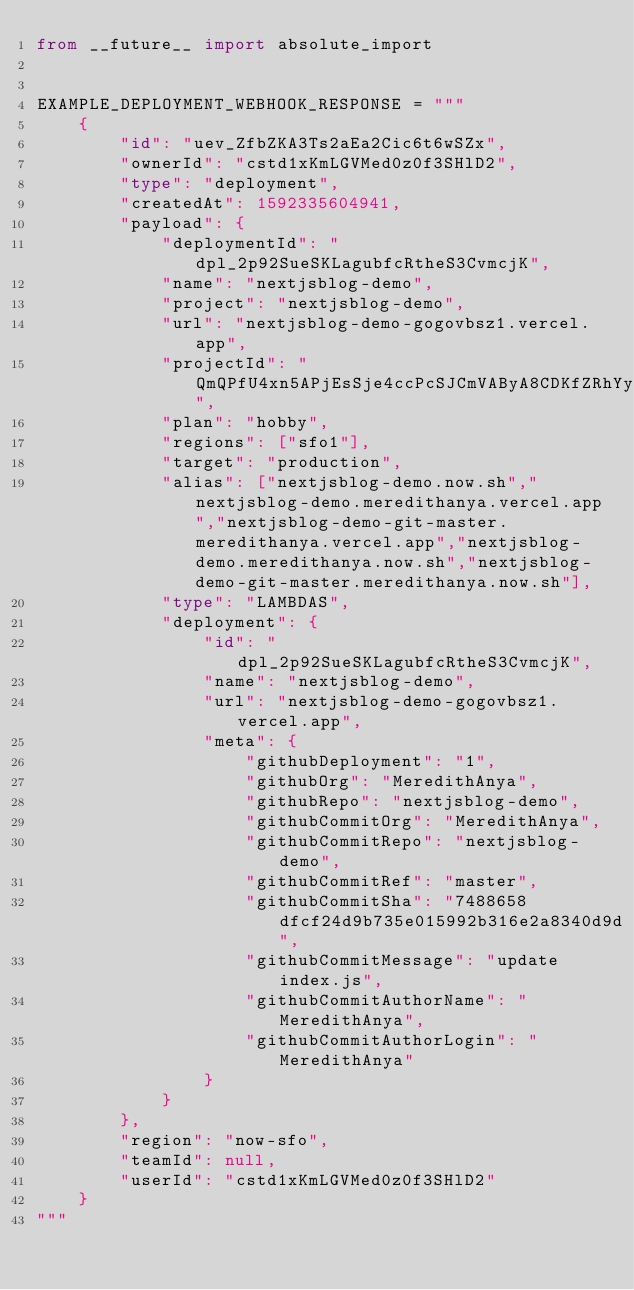<code> <loc_0><loc_0><loc_500><loc_500><_Python_>from __future__ import absolute_import


EXAMPLE_DEPLOYMENT_WEBHOOK_RESPONSE = """
    {
        "id": "uev_ZfbZKA3Ts2aEa2Cic6t6wSZx",
        "ownerId": "cstd1xKmLGVMed0z0f3SHlD2",
        "type": "deployment",
        "createdAt": 1592335604941,
        "payload": {
            "deploymentId": "dpl_2p92SueSKLagubfcRtheS3CvmcjK",
            "name": "nextjsblog-demo",
            "project": "nextjsblog-demo",
            "url": "nextjsblog-demo-gogovbsz1.vercel.app",
            "projectId": "QmQPfU4xn5APjEsSje4ccPcSJCmVAByA8CDKfZRhYyVPAg",
            "plan": "hobby",
            "regions": ["sfo1"],
            "target": "production",
            "alias": ["nextjsblog-demo.now.sh","nextjsblog-demo.meredithanya.vercel.app","nextjsblog-demo-git-master.meredithanya.vercel.app","nextjsblog-demo.meredithanya.now.sh","nextjsblog-demo-git-master.meredithanya.now.sh"],
            "type": "LAMBDAS",
            "deployment": {
                "id": "dpl_2p92SueSKLagubfcRtheS3CvmcjK",
                "name": "nextjsblog-demo",
                "url": "nextjsblog-demo-gogovbsz1.vercel.app",
                "meta": {
                    "githubDeployment": "1",
                    "githubOrg": "MeredithAnya",
                    "githubRepo": "nextjsblog-demo",
                    "githubCommitOrg": "MeredithAnya",
                    "githubCommitRepo": "nextjsblog-demo",
                    "githubCommitRef": "master",
                    "githubCommitSha": "7488658dfcf24d9b735e015992b316e2a8340d9d",
                    "githubCommitMessage": "update index.js",
                    "githubCommitAuthorName": "MeredithAnya",
                    "githubCommitAuthorLogin": "MeredithAnya"
                }
            }
        },
        "region": "now-sfo",
        "teamId": null,
        "userId": "cstd1xKmLGVMed0z0f3SHlD2"
    }
"""
</code> 